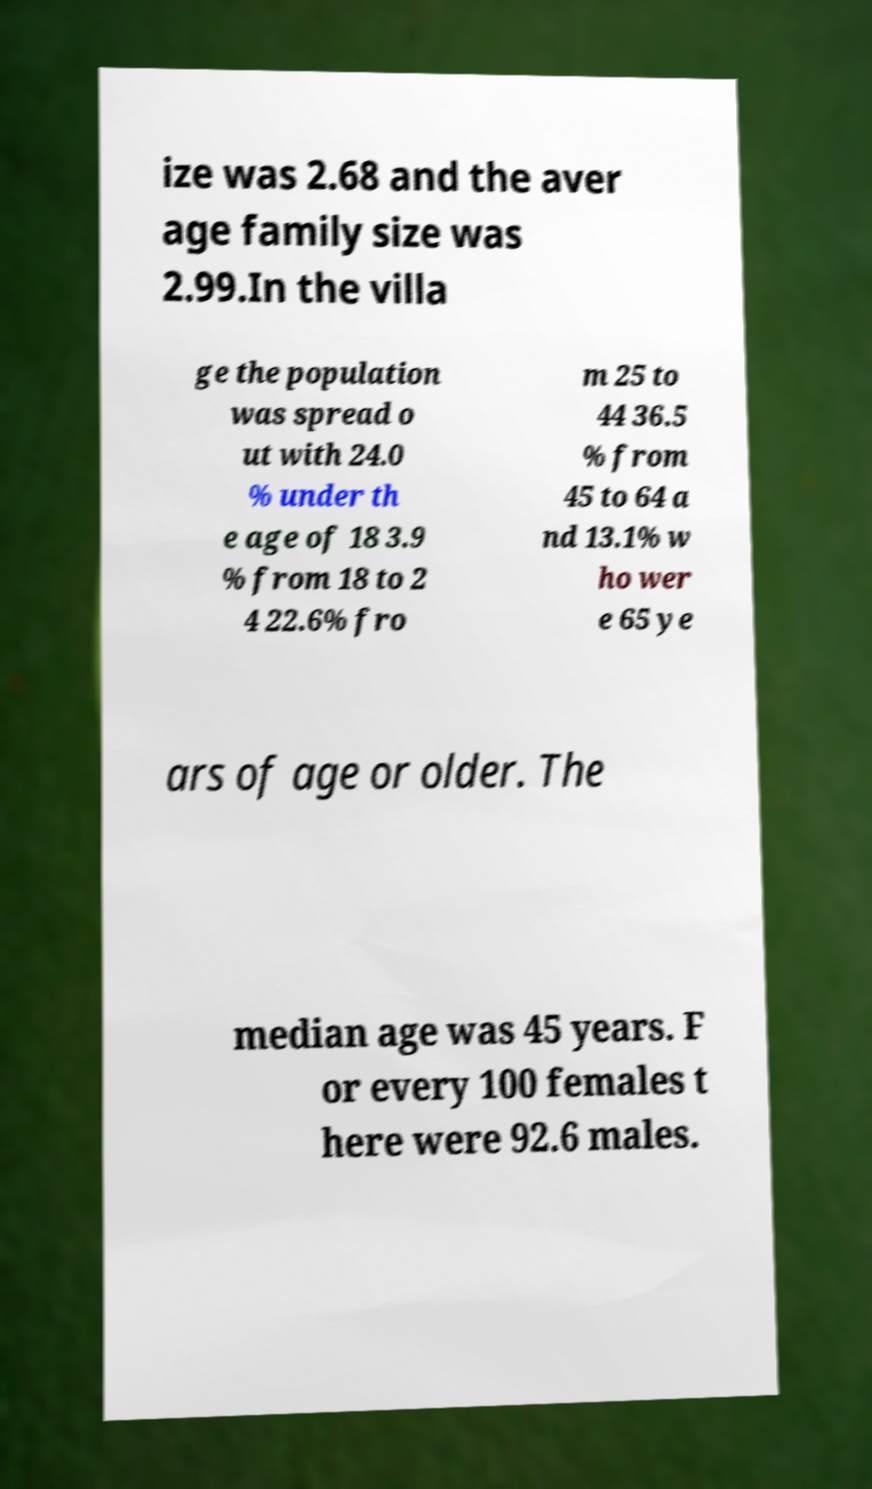Could you extract and type out the text from this image? ize was 2.68 and the aver age family size was 2.99.In the villa ge the population was spread o ut with 24.0 % under th e age of 18 3.9 % from 18 to 2 4 22.6% fro m 25 to 44 36.5 % from 45 to 64 a nd 13.1% w ho wer e 65 ye ars of age or older. The median age was 45 years. F or every 100 females t here were 92.6 males. 